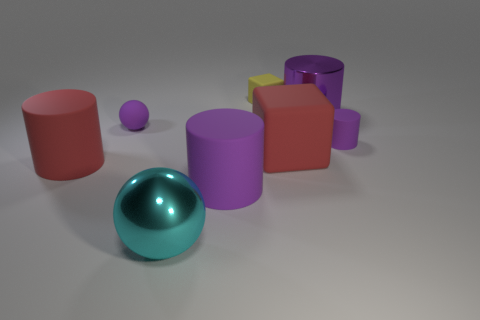Subtract all purple balls. How many purple cylinders are left? 3 Subtract all red cubes. Subtract all purple cylinders. How many cubes are left? 1 Add 2 red things. How many objects exist? 10 Subtract all balls. How many objects are left? 6 Subtract all large red things. Subtract all large cyan metallic spheres. How many objects are left? 5 Add 6 large red matte objects. How many large red matte objects are left? 8 Add 5 large purple rubber objects. How many large purple rubber objects exist? 6 Subtract 1 cyan balls. How many objects are left? 7 